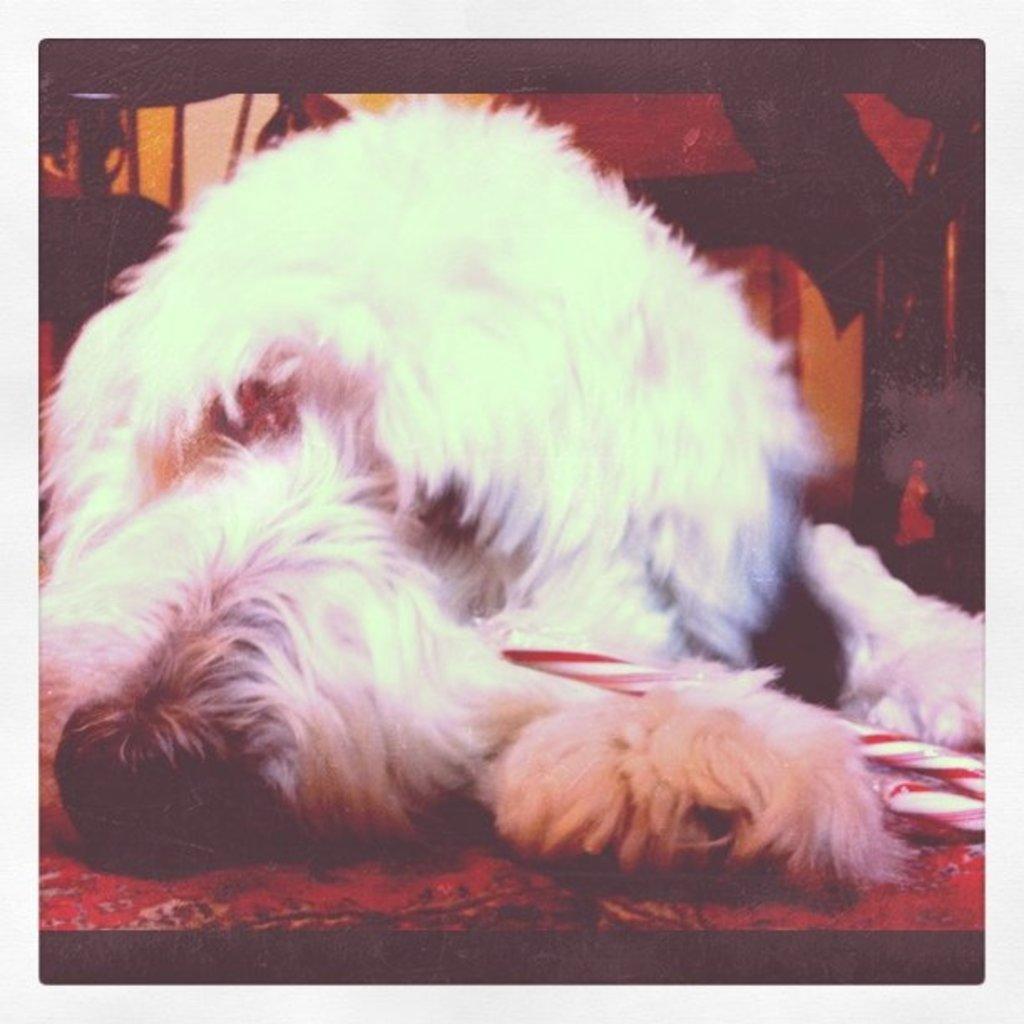Please provide a concise description of this image. In the center of the image we can see a dog is lying on the mat. On the right side of the image an object is there. 